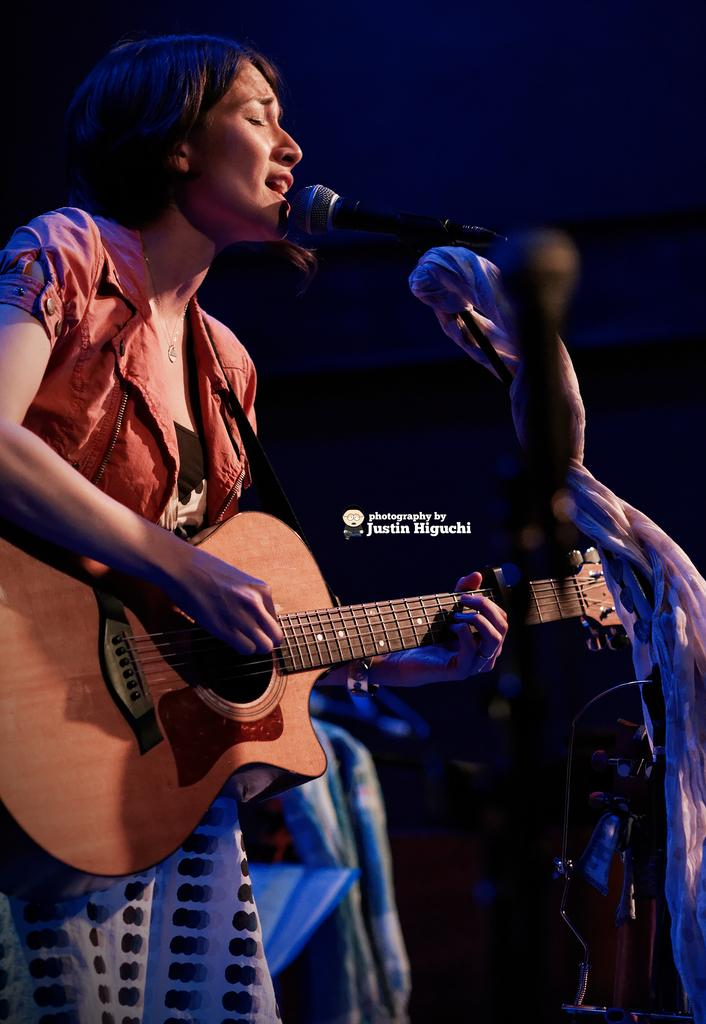What is the woman in the image doing? The woman is playing the guitar and singing on a microphone. What instrument is the woman holding in the image? The woman is holding a guitar in the image. What can be seen in the background of the image? There is a cloth in the background of the image, and the background is blurry and dark. How many ducks are visible in the image? There are no ducks present in the image. What type of work is the woman doing in the image? The image does not provide information about the woman's work, as it only shows her playing the guitar and singing on a microphone. 